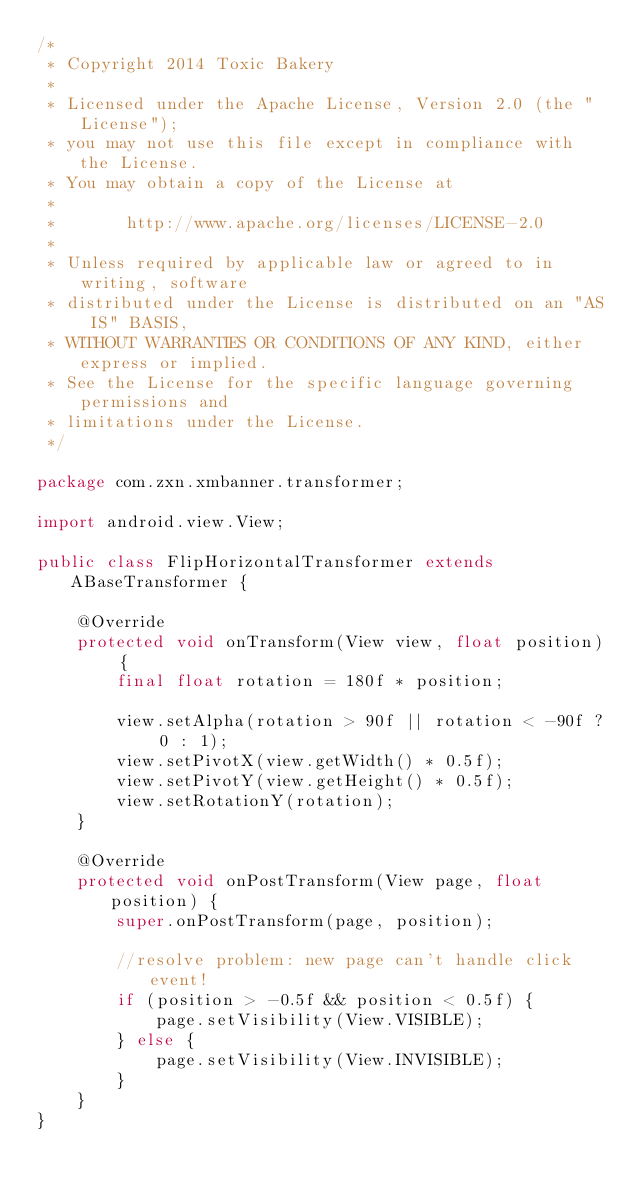<code> <loc_0><loc_0><loc_500><loc_500><_Java_>/*
 * Copyright 2014 Toxic Bakery
 *
 * Licensed under the Apache License, Version 2.0 (the "License");
 * you may not use this file except in compliance with the License.
 * You may obtain a copy of the License at
 *
 *       http://www.apache.org/licenses/LICENSE-2.0
 *
 * Unless required by applicable law or agreed to in writing, software
 * distributed under the License is distributed on an "AS IS" BASIS,
 * WITHOUT WARRANTIES OR CONDITIONS OF ANY KIND, either express or implied.
 * See the License for the specific language governing permissions and
 * limitations under the License.
 */

package com.zxn.xmbanner.transformer;

import android.view.View;

public class FlipHorizontalTransformer extends ABaseTransformer {

    @Override
    protected void onTransform(View view, float position) {
        final float rotation = 180f * position;

        view.setAlpha(rotation > 90f || rotation < -90f ? 0 : 1);
        view.setPivotX(view.getWidth() * 0.5f);
        view.setPivotY(view.getHeight() * 0.5f);
        view.setRotationY(rotation);
    }

    @Override
    protected void onPostTransform(View page, float position) {
        super.onPostTransform(page, position);

        //resolve problem: new page can't handle click event!
        if (position > -0.5f && position < 0.5f) {
            page.setVisibility(View.VISIBLE);
        } else {
            page.setVisibility(View.INVISIBLE);
        }
    }
}
</code> 